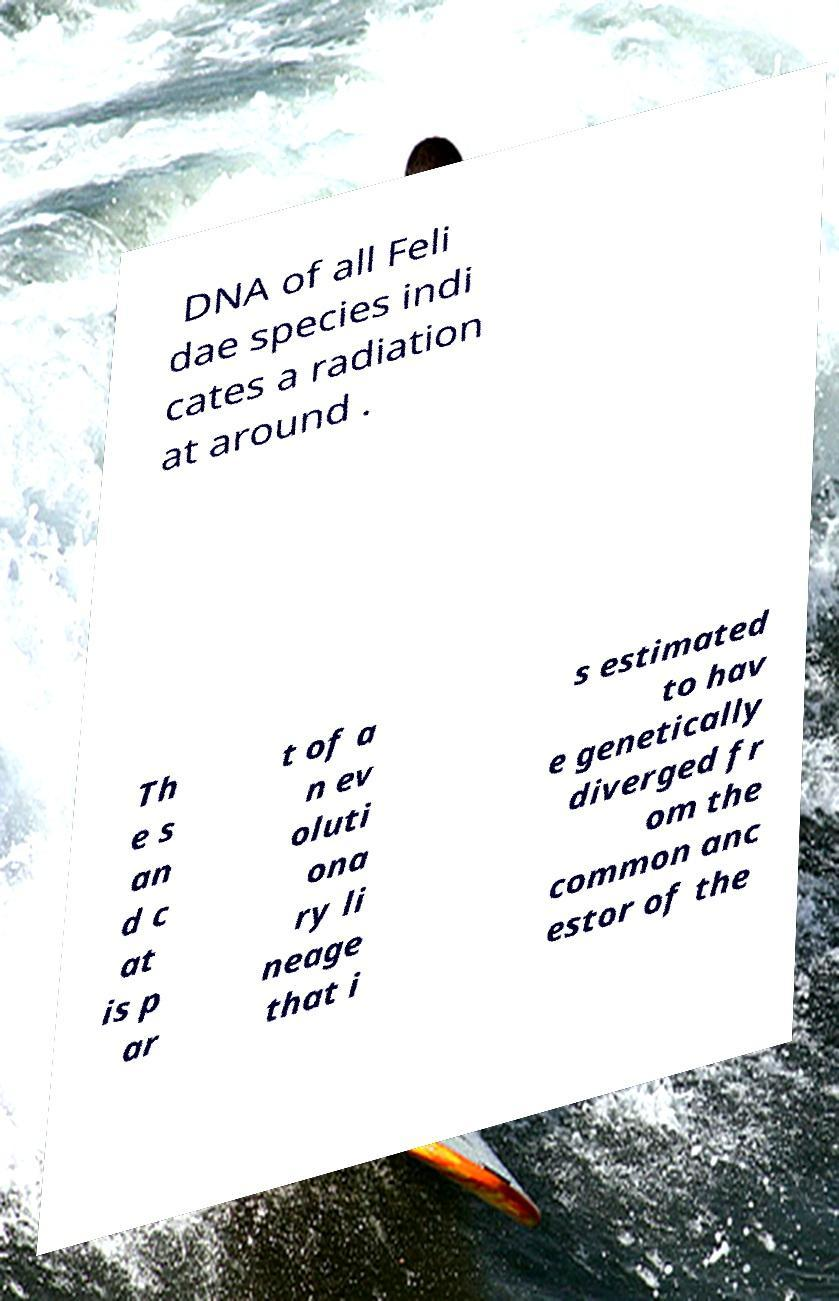What messages or text are displayed in this image? I need them in a readable, typed format. DNA of all Feli dae species indi cates a radiation at around . Th e s an d c at is p ar t of a n ev oluti ona ry li neage that i s estimated to hav e genetically diverged fr om the common anc estor of the 